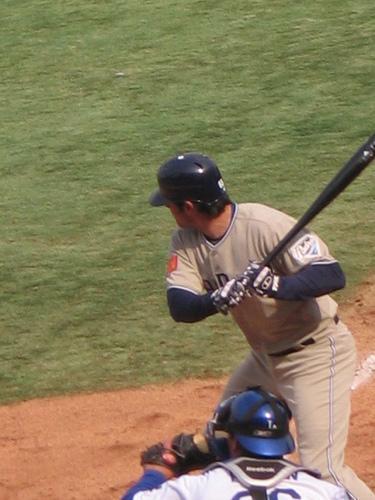How many baseball players are photographed?
Give a very brief answer. 2. 